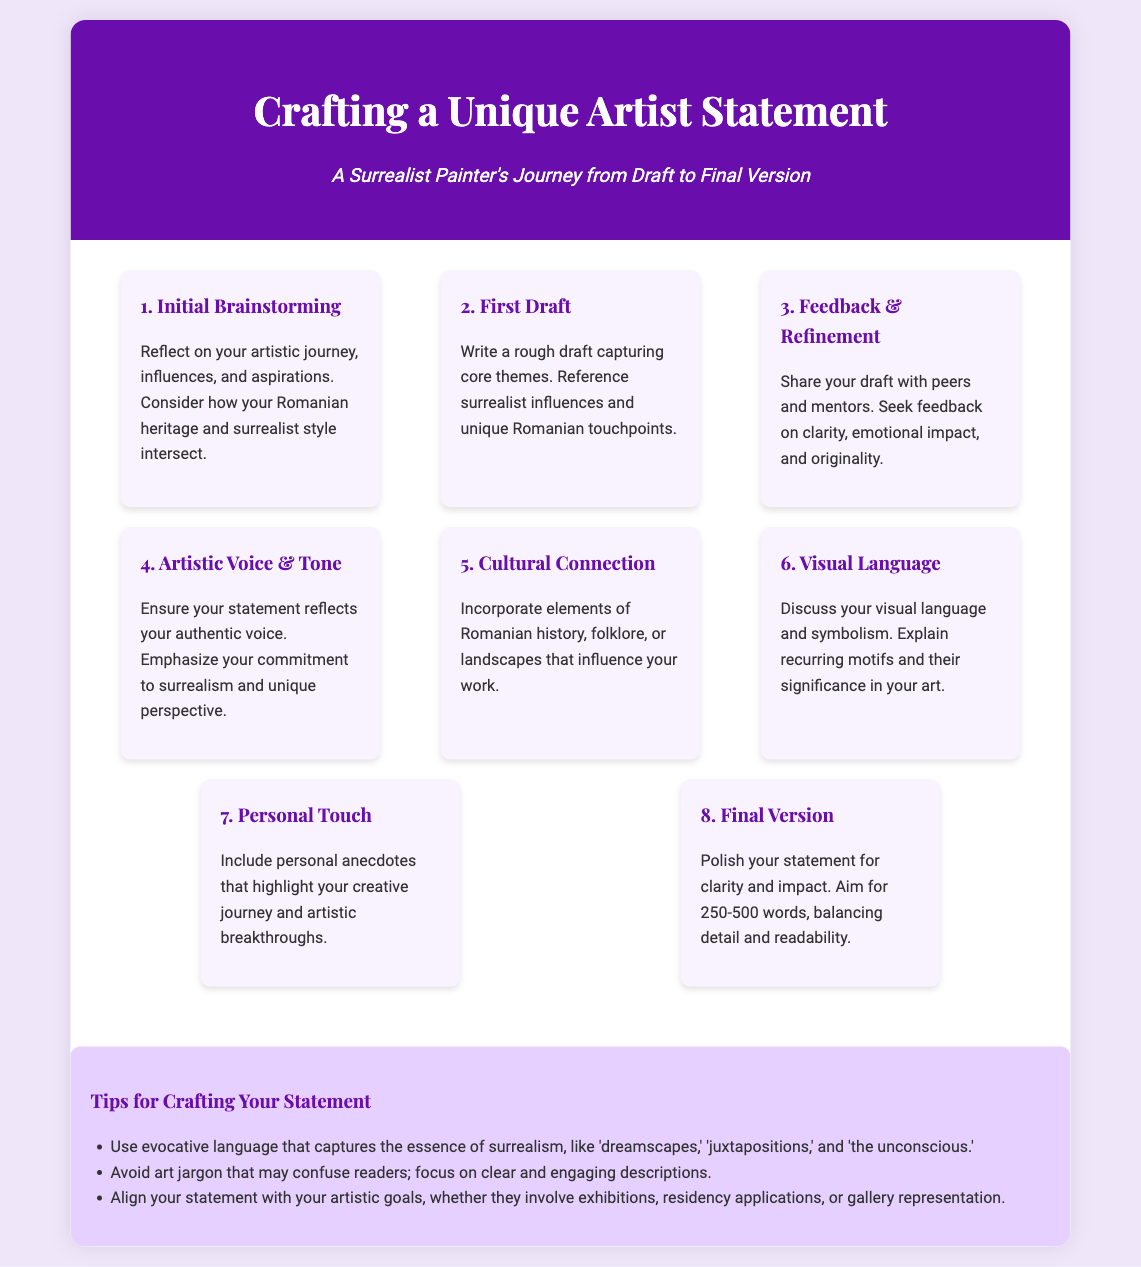what is the title of the infographic? The title is prominently displayed at the top of the document.
Answer: Crafting a Unique Artist Statement how many steps are outlined in the process? The document lists each step clearly, and counting them gives the total.
Answer: 8 what is the focus of the initial brainstorming step? The content of this step indicates what to reflect on during brainstorming.
Answer: Artistic journey, influences, and aspirations which element should be incorporated in the cultural connection step? The step specifically mentions what aspects to include.
Answer: Romanian history, folklore, or landscapes what is the recommended word count for the final version? The document explicitly states the word count range for the final statement.
Answer: 250-500 words in which step should personal anecdotes be included? The text specifies in which step to include personal stories.
Answer: Personal Touch what type of language should be used in the statement according to the tips? The tips emphasize the type of language suitable for the statement.
Answer: Evocative language what is the main purpose of crafting an artist statement? The document highlights the reasons for creating an artist statement.
Answer: To express one's artistic journey and intentions 